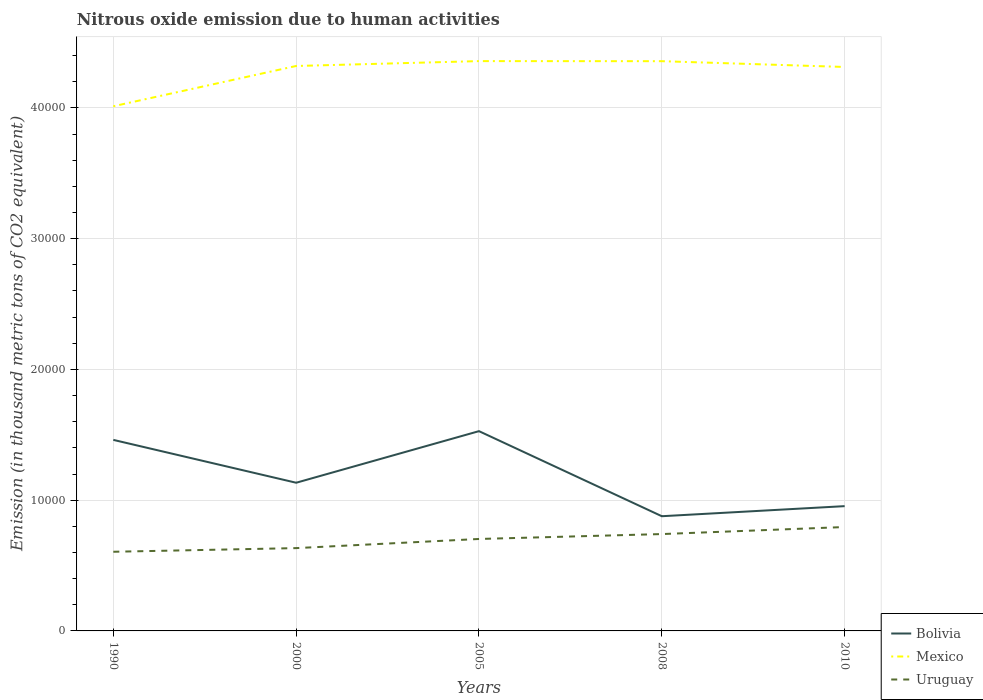Across all years, what is the maximum amount of nitrous oxide emitted in Uruguay?
Ensure brevity in your answer.  6054.9. In which year was the amount of nitrous oxide emitted in Bolivia maximum?
Your answer should be very brief. 2008. What is the total amount of nitrous oxide emitted in Mexico in the graph?
Make the answer very short. 448.7. What is the difference between the highest and the second highest amount of nitrous oxide emitted in Mexico?
Give a very brief answer. 3453. What is the difference between the highest and the lowest amount of nitrous oxide emitted in Uruguay?
Offer a very short reply. 3. Are the values on the major ticks of Y-axis written in scientific E-notation?
Give a very brief answer. No. Does the graph contain any zero values?
Your answer should be compact. No. Where does the legend appear in the graph?
Ensure brevity in your answer.  Bottom right. How are the legend labels stacked?
Your answer should be compact. Vertical. What is the title of the graph?
Offer a terse response. Nitrous oxide emission due to human activities. What is the label or title of the Y-axis?
Keep it short and to the point. Emission (in thousand metric tons of CO2 equivalent). What is the Emission (in thousand metric tons of CO2 equivalent) of Bolivia in 1990?
Make the answer very short. 1.46e+04. What is the Emission (in thousand metric tons of CO2 equivalent) of Mexico in 1990?
Offer a terse response. 4.01e+04. What is the Emission (in thousand metric tons of CO2 equivalent) of Uruguay in 1990?
Offer a terse response. 6054.9. What is the Emission (in thousand metric tons of CO2 equivalent) in Bolivia in 2000?
Provide a succinct answer. 1.13e+04. What is the Emission (in thousand metric tons of CO2 equivalent) of Mexico in 2000?
Ensure brevity in your answer.  4.32e+04. What is the Emission (in thousand metric tons of CO2 equivalent) of Uruguay in 2000?
Your answer should be very brief. 6333.8. What is the Emission (in thousand metric tons of CO2 equivalent) in Bolivia in 2005?
Keep it short and to the point. 1.53e+04. What is the Emission (in thousand metric tons of CO2 equivalent) of Mexico in 2005?
Your response must be concise. 4.36e+04. What is the Emission (in thousand metric tons of CO2 equivalent) of Uruguay in 2005?
Provide a succinct answer. 7032.9. What is the Emission (in thousand metric tons of CO2 equivalent) of Bolivia in 2008?
Your response must be concise. 8773. What is the Emission (in thousand metric tons of CO2 equivalent) in Mexico in 2008?
Provide a short and direct response. 4.36e+04. What is the Emission (in thousand metric tons of CO2 equivalent) of Uruguay in 2008?
Provide a succinct answer. 7408. What is the Emission (in thousand metric tons of CO2 equivalent) in Bolivia in 2010?
Keep it short and to the point. 9543.7. What is the Emission (in thousand metric tons of CO2 equivalent) of Mexico in 2010?
Provide a succinct answer. 4.31e+04. What is the Emission (in thousand metric tons of CO2 equivalent) in Uruguay in 2010?
Provide a short and direct response. 7946.5. Across all years, what is the maximum Emission (in thousand metric tons of CO2 equivalent) in Bolivia?
Offer a very short reply. 1.53e+04. Across all years, what is the maximum Emission (in thousand metric tons of CO2 equivalent) of Mexico?
Provide a succinct answer. 4.36e+04. Across all years, what is the maximum Emission (in thousand metric tons of CO2 equivalent) in Uruguay?
Keep it short and to the point. 7946.5. Across all years, what is the minimum Emission (in thousand metric tons of CO2 equivalent) of Bolivia?
Offer a very short reply. 8773. Across all years, what is the minimum Emission (in thousand metric tons of CO2 equivalent) in Mexico?
Ensure brevity in your answer.  4.01e+04. Across all years, what is the minimum Emission (in thousand metric tons of CO2 equivalent) of Uruguay?
Your answer should be very brief. 6054.9. What is the total Emission (in thousand metric tons of CO2 equivalent) in Bolivia in the graph?
Ensure brevity in your answer.  5.95e+04. What is the total Emission (in thousand metric tons of CO2 equivalent) in Mexico in the graph?
Keep it short and to the point. 2.14e+05. What is the total Emission (in thousand metric tons of CO2 equivalent) in Uruguay in the graph?
Make the answer very short. 3.48e+04. What is the difference between the Emission (in thousand metric tons of CO2 equivalent) of Bolivia in 1990 and that in 2000?
Offer a very short reply. 3277.5. What is the difference between the Emission (in thousand metric tons of CO2 equivalent) in Mexico in 1990 and that in 2000?
Keep it short and to the point. -3080.7. What is the difference between the Emission (in thousand metric tons of CO2 equivalent) of Uruguay in 1990 and that in 2000?
Offer a terse response. -278.9. What is the difference between the Emission (in thousand metric tons of CO2 equivalent) of Bolivia in 1990 and that in 2005?
Give a very brief answer. -667.9. What is the difference between the Emission (in thousand metric tons of CO2 equivalent) of Mexico in 1990 and that in 2005?
Your answer should be very brief. -3453. What is the difference between the Emission (in thousand metric tons of CO2 equivalent) in Uruguay in 1990 and that in 2005?
Provide a short and direct response. -978. What is the difference between the Emission (in thousand metric tons of CO2 equivalent) in Bolivia in 1990 and that in 2008?
Make the answer very short. 5838.6. What is the difference between the Emission (in thousand metric tons of CO2 equivalent) in Mexico in 1990 and that in 2008?
Ensure brevity in your answer.  -3446.9. What is the difference between the Emission (in thousand metric tons of CO2 equivalent) of Uruguay in 1990 and that in 2008?
Make the answer very short. -1353.1. What is the difference between the Emission (in thousand metric tons of CO2 equivalent) of Bolivia in 1990 and that in 2010?
Make the answer very short. 5067.9. What is the difference between the Emission (in thousand metric tons of CO2 equivalent) in Mexico in 1990 and that in 2010?
Provide a succinct answer. -3004.3. What is the difference between the Emission (in thousand metric tons of CO2 equivalent) in Uruguay in 1990 and that in 2010?
Your answer should be compact. -1891.6. What is the difference between the Emission (in thousand metric tons of CO2 equivalent) of Bolivia in 2000 and that in 2005?
Your answer should be compact. -3945.4. What is the difference between the Emission (in thousand metric tons of CO2 equivalent) of Mexico in 2000 and that in 2005?
Your answer should be very brief. -372.3. What is the difference between the Emission (in thousand metric tons of CO2 equivalent) of Uruguay in 2000 and that in 2005?
Offer a terse response. -699.1. What is the difference between the Emission (in thousand metric tons of CO2 equivalent) of Bolivia in 2000 and that in 2008?
Provide a succinct answer. 2561.1. What is the difference between the Emission (in thousand metric tons of CO2 equivalent) in Mexico in 2000 and that in 2008?
Keep it short and to the point. -366.2. What is the difference between the Emission (in thousand metric tons of CO2 equivalent) in Uruguay in 2000 and that in 2008?
Provide a short and direct response. -1074.2. What is the difference between the Emission (in thousand metric tons of CO2 equivalent) in Bolivia in 2000 and that in 2010?
Provide a short and direct response. 1790.4. What is the difference between the Emission (in thousand metric tons of CO2 equivalent) of Mexico in 2000 and that in 2010?
Ensure brevity in your answer.  76.4. What is the difference between the Emission (in thousand metric tons of CO2 equivalent) of Uruguay in 2000 and that in 2010?
Provide a short and direct response. -1612.7. What is the difference between the Emission (in thousand metric tons of CO2 equivalent) in Bolivia in 2005 and that in 2008?
Your response must be concise. 6506.5. What is the difference between the Emission (in thousand metric tons of CO2 equivalent) in Uruguay in 2005 and that in 2008?
Make the answer very short. -375.1. What is the difference between the Emission (in thousand metric tons of CO2 equivalent) in Bolivia in 2005 and that in 2010?
Provide a short and direct response. 5735.8. What is the difference between the Emission (in thousand metric tons of CO2 equivalent) in Mexico in 2005 and that in 2010?
Offer a very short reply. 448.7. What is the difference between the Emission (in thousand metric tons of CO2 equivalent) in Uruguay in 2005 and that in 2010?
Ensure brevity in your answer.  -913.6. What is the difference between the Emission (in thousand metric tons of CO2 equivalent) of Bolivia in 2008 and that in 2010?
Make the answer very short. -770.7. What is the difference between the Emission (in thousand metric tons of CO2 equivalent) in Mexico in 2008 and that in 2010?
Your answer should be very brief. 442.6. What is the difference between the Emission (in thousand metric tons of CO2 equivalent) in Uruguay in 2008 and that in 2010?
Offer a very short reply. -538.5. What is the difference between the Emission (in thousand metric tons of CO2 equivalent) in Bolivia in 1990 and the Emission (in thousand metric tons of CO2 equivalent) in Mexico in 2000?
Your answer should be compact. -2.86e+04. What is the difference between the Emission (in thousand metric tons of CO2 equivalent) in Bolivia in 1990 and the Emission (in thousand metric tons of CO2 equivalent) in Uruguay in 2000?
Keep it short and to the point. 8277.8. What is the difference between the Emission (in thousand metric tons of CO2 equivalent) of Mexico in 1990 and the Emission (in thousand metric tons of CO2 equivalent) of Uruguay in 2000?
Provide a succinct answer. 3.38e+04. What is the difference between the Emission (in thousand metric tons of CO2 equivalent) of Bolivia in 1990 and the Emission (in thousand metric tons of CO2 equivalent) of Mexico in 2005?
Your answer should be very brief. -2.90e+04. What is the difference between the Emission (in thousand metric tons of CO2 equivalent) of Bolivia in 1990 and the Emission (in thousand metric tons of CO2 equivalent) of Uruguay in 2005?
Your answer should be very brief. 7578.7. What is the difference between the Emission (in thousand metric tons of CO2 equivalent) in Mexico in 1990 and the Emission (in thousand metric tons of CO2 equivalent) in Uruguay in 2005?
Offer a terse response. 3.31e+04. What is the difference between the Emission (in thousand metric tons of CO2 equivalent) of Bolivia in 1990 and the Emission (in thousand metric tons of CO2 equivalent) of Mexico in 2008?
Give a very brief answer. -2.90e+04. What is the difference between the Emission (in thousand metric tons of CO2 equivalent) of Bolivia in 1990 and the Emission (in thousand metric tons of CO2 equivalent) of Uruguay in 2008?
Give a very brief answer. 7203.6. What is the difference between the Emission (in thousand metric tons of CO2 equivalent) of Mexico in 1990 and the Emission (in thousand metric tons of CO2 equivalent) of Uruguay in 2008?
Offer a very short reply. 3.27e+04. What is the difference between the Emission (in thousand metric tons of CO2 equivalent) in Bolivia in 1990 and the Emission (in thousand metric tons of CO2 equivalent) in Mexico in 2010?
Your response must be concise. -2.85e+04. What is the difference between the Emission (in thousand metric tons of CO2 equivalent) in Bolivia in 1990 and the Emission (in thousand metric tons of CO2 equivalent) in Uruguay in 2010?
Provide a succinct answer. 6665.1. What is the difference between the Emission (in thousand metric tons of CO2 equivalent) in Mexico in 1990 and the Emission (in thousand metric tons of CO2 equivalent) in Uruguay in 2010?
Offer a terse response. 3.22e+04. What is the difference between the Emission (in thousand metric tons of CO2 equivalent) in Bolivia in 2000 and the Emission (in thousand metric tons of CO2 equivalent) in Mexico in 2005?
Your response must be concise. -3.22e+04. What is the difference between the Emission (in thousand metric tons of CO2 equivalent) in Bolivia in 2000 and the Emission (in thousand metric tons of CO2 equivalent) in Uruguay in 2005?
Provide a succinct answer. 4301.2. What is the difference between the Emission (in thousand metric tons of CO2 equivalent) of Mexico in 2000 and the Emission (in thousand metric tons of CO2 equivalent) of Uruguay in 2005?
Provide a succinct answer. 3.62e+04. What is the difference between the Emission (in thousand metric tons of CO2 equivalent) of Bolivia in 2000 and the Emission (in thousand metric tons of CO2 equivalent) of Mexico in 2008?
Give a very brief answer. -3.22e+04. What is the difference between the Emission (in thousand metric tons of CO2 equivalent) in Bolivia in 2000 and the Emission (in thousand metric tons of CO2 equivalent) in Uruguay in 2008?
Your answer should be compact. 3926.1. What is the difference between the Emission (in thousand metric tons of CO2 equivalent) in Mexico in 2000 and the Emission (in thousand metric tons of CO2 equivalent) in Uruguay in 2008?
Make the answer very short. 3.58e+04. What is the difference between the Emission (in thousand metric tons of CO2 equivalent) in Bolivia in 2000 and the Emission (in thousand metric tons of CO2 equivalent) in Mexico in 2010?
Offer a terse response. -3.18e+04. What is the difference between the Emission (in thousand metric tons of CO2 equivalent) of Bolivia in 2000 and the Emission (in thousand metric tons of CO2 equivalent) of Uruguay in 2010?
Your answer should be very brief. 3387.6. What is the difference between the Emission (in thousand metric tons of CO2 equivalent) of Mexico in 2000 and the Emission (in thousand metric tons of CO2 equivalent) of Uruguay in 2010?
Offer a very short reply. 3.53e+04. What is the difference between the Emission (in thousand metric tons of CO2 equivalent) of Bolivia in 2005 and the Emission (in thousand metric tons of CO2 equivalent) of Mexico in 2008?
Your response must be concise. -2.83e+04. What is the difference between the Emission (in thousand metric tons of CO2 equivalent) of Bolivia in 2005 and the Emission (in thousand metric tons of CO2 equivalent) of Uruguay in 2008?
Give a very brief answer. 7871.5. What is the difference between the Emission (in thousand metric tons of CO2 equivalent) in Mexico in 2005 and the Emission (in thousand metric tons of CO2 equivalent) in Uruguay in 2008?
Your answer should be compact. 3.62e+04. What is the difference between the Emission (in thousand metric tons of CO2 equivalent) in Bolivia in 2005 and the Emission (in thousand metric tons of CO2 equivalent) in Mexico in 2010?
Your answer should be compact. -2.79e+04. What is the difference between the Emission (in thousand metric tons of CO2 equivalent) in Bolivia in 2005 and the Emission (in thousand metric tons of CO2 equivalent) in Uruguay in 2010?
Provide a short and direct response. 7333. What is the difference between the Emission (in thousand metric tons of CO2 equivalent) of Mexico in 2005 and the Emission (in thousand metric tons of CO2 equivalent) of Uruguay in 2010?
Make the answer very short. 3.56e+04. What is the difference between the Emission (in thousand metric tons of CO2 equivalent) of Bolivia in 2008 and the Emission (in thousand metric tons of CO2 equivalent) of Mexico in 2010?
Provide a short and direct response. -3.44e+04. What is the difference between the Emission (in thousand metric tons of CO2 equivalent) of Bolivia in 2008 and the Emission (in thousand metric tons of CO2 equivalent) of Uruguay in 2010?
Your answer should be compact. 826.5. What is the difference between the Emission (in thousand metric tons of CO2 equivalent) in Mexico in 2008 and the Emission (in thousand metric tons of CO2 equivalent) in Uruguay in 2010?
Keep it short and to the point. 3.56e+04. What is the average Emission (in thousand metric tons of CO2 equivalent) of Bolivia per year?
Your response must be concise. 1.19e+04. What is the average Emission (in thousand metric tons of CO2 equivalent) of Mexico per year?
Your answer should be very brief. 4.27e+04. What is the average Emission (in thousand metric tons of CO2 equivalent) in Uruguay per year?
Your answer should be compact. 6955.22. In the year 1990, what is the difference between the Emission (in thousand metric tons of CO2 equivalent) in Bolivia and Emission (in thousand metric tons of CO2 equivalent) in Mexico?
Make the answer very short. -2.55e+04. In the year 1990, what is the difference between the Emission (in thousand metric tons of CO2 equivalent) of Bolivia and Emission (in thousand metric tons of CO2 equivalent) of Uruguay?
Your response must be concise. 8556.7. In the year 1990, what is the difference between the Emission (in thousand metric tons of CO2 equivalent) in Mexico and Emission (in thousand metric tons of CO2 equivalent) in Uruguay?
Provide a succinct answer. 3.41e+04. In the year 2000, what is the difference between the Emission (in thousand metric tons of CO2 equivalent) in Bolivia and Emission (in thousand metric tons of CO2 equivalent) in Mexico?
Offer a very short reply. -3.19e+04. In the year 2000, what is the difference between the Emission (in thousand metric tons of CO2 equivalent) of Bolivia and Emission (in thousand metric tons of CO2 equivalent) of Uruguay?
Provide a short and direct response. 5000.3. In the year 2000, what is the difference between the Emission (in thousand metric tons of CO2 equivalent) of Mexico and Emission (in thousand metric tons of CO2 equivalent) of Uruguay?
Offer a terse response. 3.69e+04. In the year 2005, what is the difference between the Emission (in thousand metric tons of CO2 equivalent) in Bolivia and Emission (in thousand metric tons of CO2 equivalent) in Mexico?
Ensure brevity in your answer.  -2.83e+04. In the year 2005, what is the difference between the Emission (in thousand metric tons of CO2 equivalent) in Bolivia and Emission (in thousand metric tons of CO2 equivalent) in Uruguay?
Keep it short and to the point. 8246.6. In the year 2005, what is the difference between the Emission (in thousand metric tons of CO2 equivalent) in Mexico and Emission (in thousand metric tons of CO2 equivalent) in Uruguay?
Make the answer very short. 3.66e+04. In the year 2008, what is the difference between the Emission (in thousand metric tons of CO2 equivalent) of Bolivia and Emission (in thousand metric tons of CO2 equivalent) of Mexico?
Provide a short and direct response. -3.48e+04. In the year 2008, what is the difference between the Emission (in thousand metric tons of CO2 equivalent) in Bolivia and Emission (in thousand metric tons of CO2 equivalent) in Uruguay?
Keep it short and to the point. 1365. In the year 2008, what is the difference between the Emission (in thousand metric tons of CO2 equivalent) of Mexico and Emission (in thousand metric tons of CO2 equivalent) of Uruguay?
Provide a succinct answer. 3.62e+04. In the year 2010, what is the difference between the Emission (in thousand metric tons of CO2 equivalent) in Bolivia and Emission (in thousand metric tons of CO2 equivalent) in Mexico?
Your answer should be compact. -3.36e+04. In the year 2010, what is the difference between the Emission (in thousand metric tons of CO2 equivalent) in Bolivia and Emission (in thousand metric tons of CO2 equivalent) in Uruguay?
Make the answer very short. 1597.2. In the year 2010, what is the difference between the Emission (in thousand metric tons of CO2 equivalent) of Mexico and Emission (in thousand metric tons of CO2 equivalent) of Uruguay?
Provide a succinct answer. 3.52e+04. What is the ratio of the Emission (in thousand metric tons of CO2 equivalent) in Bolivia in 1990 to that in 2000?
Provide a succinct answer. 1.29. What is the ratio of the Emission (in thousand metric tons of CO2 equivalent) of Mexico in 1990 to that in 2000?
Your response must be concise. 0.93. What is the ratio of the Emission (in thousand metric tons of CO2 equivalent) in Uruguay in 1990 to that in 2000?
Make the answer very short. 0.96. What is the ratio of the Emission (in thousand metric tons of CO2 equivalent) of Bolivia in 1990 to that in 2005?
Offer a terse response. 0.96. What is the ratio of the Emission (in thousand metric tons of CO2 equivalent) of Mexico in 1990 to that in 2005?
Your answer should be compact. 0.92. What is the ratio of the Emission (in thousand metric tons of CO2 equivalent) in Uruguay in 1990 to that in 2005?
Offer a very short reply. 0.86. What is the ratio of the Emission (in thousand metric tons of CO2 equivalent) in Bolivia in 1990 to that in 2008?
Provide a short and direct response. 1.67. What is the ratio of the Emission (in thousand metric tons of CO2 equivalent) of Mexico in 1990 to that in 2008?
Give a very brief answer. 0.92. What is the ratio of the Emission (in thousand metric tons of CO2 equivalent) in Uruguay in 1990 to that in 2008?
Provide a succinct answer. 0.82. What is the ratio of the Emission (in thousand metric tons of CO2 equivalent) in Bolivia in 1990 to that in 2010?
Give a very brief answer. 1.53. What is the ratio of the Emission (in thousand metric tons of CO2 equivalent) of Mexico in 1990 to that in 2010?
Provide a succinct answer. 0.93. What is the ratio of the Emission (in thousand metric tons of CO2 equivalent) of Uruguay in 1990 to that in 2010?
Provide a succinct answer. 0.76. What is the ratio of the Emission (in thousand metric tons of CO2 equivalent) of Bolivia in 2000 to that in 2005?
Your response must be concise. 0.74. What is the ratio of the Emission (in thousand metric tons of CO2 equivalent) in Uruguay in 2000 to that in 2005?
Provide a succinct answer. 0.9. What is the ratio of the Emission (in thousand metric tons of CO2 equivalent) of Bolivia in 2000 to that in 2008?
Your response must be concise. 1.29. What is the ratio of the Emission (in thousand metric tons of CO2 equivalent) of Uruguay in 2000 to that in 2008?
Offer a very short reply. 0.85. What is the ratio of the Emission (in thousand metric tons of CO2 equivalent) in Bolivia in 2000 to that in 2010?
Your answer should be compact. 1.19. What is the ratio of the Emission (in thousand metric tons of CO2 equivalent) of Uruguay in 2000 to that in 2010?
Make the answer very short. 0.8. What is the ratio of the Emission (in thousand metric tons of CO2 equivalent) of Bolivia in 2005 to that in 2008?
Your answer should be compact. 1.74. What is the ratio of the Emission (in thousand metric tons of CO2 equivalent) in Uruguay in 2005 to that in 2008?
Make the answer very short. 0.95. What is the ratio of the Emission (in thousand metric tons of CO2 equivalent) of Bolivia in 2005 to that in 2010?
Provide a short and direct response. 1.6. What is the ratio of the Emission (in thousand metric tons of CO2 equivalent) in Mexico in 2005 to that in 2010?
Ensure brevity in your answer.  1.01. What is the ratio of the Emission (in thousand metric tons of CO2 equivalent) of Uruguay in 2005 to that in 2010?
Ensure brevity in your answer.  0.89. What is the ratio of the Emission (in thousand metric tons of CO2 equivalent) in Bolivia in 2008 to that in 2010?
Your response must be concise. 0.92. What is the ratio of the Emission (in thousand metric tons of CO2 equivalent) in Mexico in 2008 to that in 2010?
Provide a succinct answer. 1.01. What is the ratio of the Emission (in thousand metric tons of CO2 equivalent) of Uruguay in 2008 to that in 2010?
Give a very brief answer. 0.93. What is the difference between the highest and the second highest Emission (in thousand metric tons of CO2 equivalent) in Bolivia?
Give a very brief answer. 667.9. What is the difference between the highest and the second highest Emission (in thousand metric tons of CO2 equivalent) of Mexico?
Your answer should be compact. 6.1. What is the difference between the highest and the second highest Emission (in thousand metric tons of CO2 equivalent) in Uruguay?
Your answer should be compact. 538.5. What is the difference between the highest and the lowest Emission (in thousand metric tons of CO2 equivalent) of Bolivia?
Offer a very short reply. 6506.5. What is the difference between the highest and the lowest Emission (in thousand metric tons of CO2 equivalent) of Mexico?
Your response must be concise. 3453. What is the difference between the highest and the lowest Emission (in thousand metric tons of CO2 equivalent) in Uruguay?
Keep it short and to the point. 1891.6. 